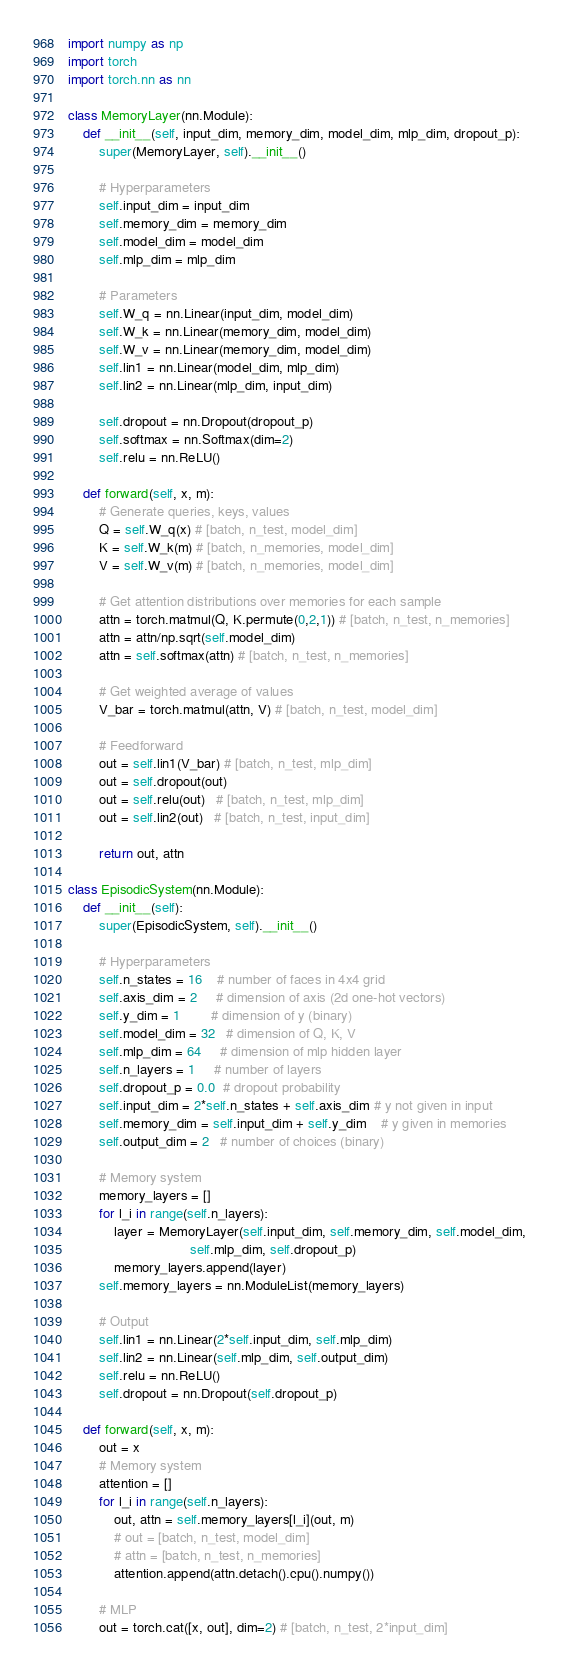Convert code to text. <code><loc_0><loc_0><loc_500><loc_500><_Python_>import numpy as np
import torch
import torch.nn as nn

class MemoryLayer(nn.Module):
    def __init__(self, input_dim, memory_dim, model_dim, mlp_dim, dropout_p):
        super(MemoryLayer, self).__init__()
        
        # Hyperparameters
        self.input_dim = input_dim
        self.memory_dim = memory_dim
        self.model_dim = model_dim
        self.mlp_dim = mlp_dim
        
        # Parameters
        self.W_q = nn.Linear(input_dim, model_dim)
        self.W_k = nn.Linear(memory_dim, model_dim)
        self.W_v = nn.Linear(memory_dim, model_dim)
        self.lin1 = nn.Linear(model_dim, mlp_dim)
        self.lin2 = nn.Linear(mlp_dim, input_dim)
        
        self.dropout = nn.Dropout(dropout_p)
        self.softmax = nn.Softmax(dim=2)
        self.relu = nn.ReLU()
        
    def forward(self, x, m):
        # Generate queries, keys, values
        Q = self.W_q(x) # [batch, n_test, model_dim]
        K = self.W_k(m) # [batch, n_memories, model_dim]
        V = self.W_v(m) # [batch, n_memories, model_dim]
        
        # Get attention distributions over memories for each sample
        attn = torch.matmul(Q, K.permute(0,2,1)) # [batch, n_test, n_memories]
        attn = attn/np.sqrt(self.model_dim)
        attn = self.softmax(attn) # [batch, n_test, n_memories]
        
        # Get weighted average of values
        V_bar = torch.matmul(attn, V) # [batch, n_test, model_dim]
        
        # Feedforward
        out = self.lin1(V_bar) # [batch, n_test, mlp_dim]
        out = self.dropout(out)
        out = self.relu(out)   # [batch, n_test, mlp_dim]
        out = self.lin2(out)   # [batch, n_test, input_dim]
        
        return out, attn
        
class EpisodicSystem(nn.Module):
    def __init__(self):
        super(EpisodicSystem, self).__init__()

        # Hyperparameters
        self.n_states = 16    # number of faces in 4x4 grid
        self.axis_dim = 2     # dimension of axis (2d one-hot vectors)
        self.y_dim = 1        # dimension of y (binary)
        self.model_dim = 32   # dimension of Q, K, V
        self.mlp_dim = 64     # dimension of mlp hidden layer
        self.n_layers = 1     # number of layers
        self.dropout_p = 0.0  # dropout probability
        self.input_dim = 2*self.n_states + self.axis_dim # y not given in input
        self.memory_dim = self.input_dim + self.y_dim    # y given in memories
        self.output_dim = 2   # number of choices (binary)
        
        # Memory system
        memory_layers = []
        for l_i in range(self.n_layers):
            layer = MemoryLayer(self.input_dim, self.memory_dim, self.model_dim, 
                                self.mlp_dim, self.dropout_p)
            memory_layers.append(layer)
        self.memory_layers = nn.ModuleList(memory_layers)
        
        # Output
        self.lin1 = nn.Linear(2*self.input_dim, self.mlp_dim)
        self.lin2 = nn.Linear(self.mlp_dim, self.output_dim)
        self.relu = nn.ReLU()
        self.dropout = nn.Dropout(self.dropout_p)
        
    def forward(self, x, m):
        out = x
        # Memory system
        attention = []
        for l_i in range(self.n_layers):
            out, attn = self.memory_layers[l_i](out, m) 
            # out = [batch, n_test, model_dim]
            # attn = [batch, n_test, n_memories]
            attention.append(attn.detach().cpu().numpy())
        
        # MLP
        out = torch.cat([x, out], dim=2) # [batch, n_test, 2*input_dim]</code> 